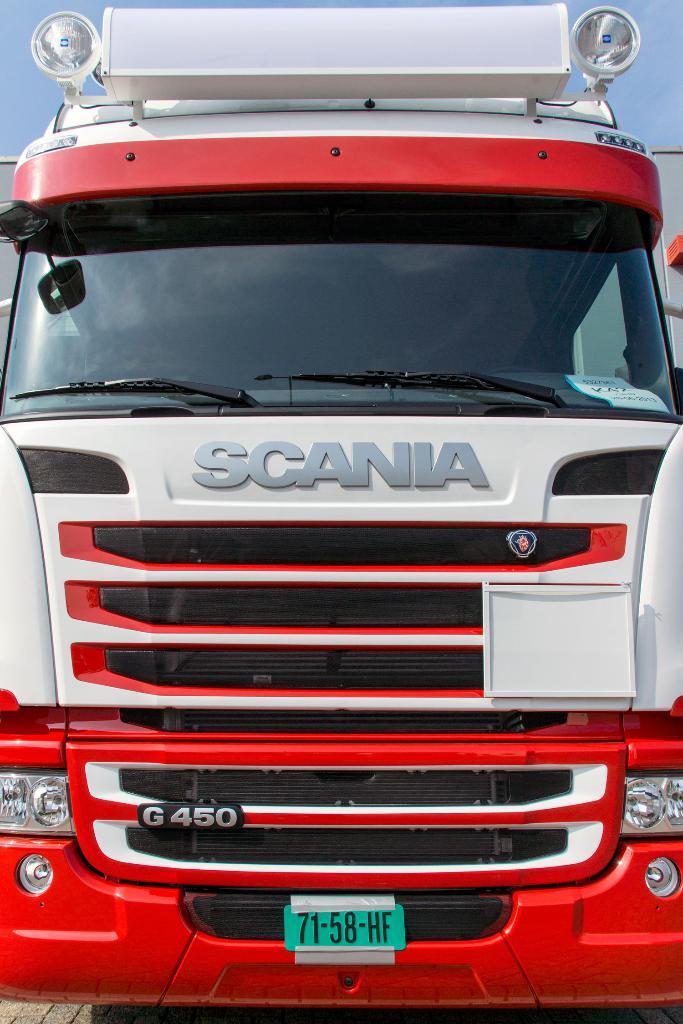Could you give a brief overview of what you see in this image? There is a vehicle in the foreground, there are lamps at the top of it, it seems like another vehicle and the sky in the background area. 